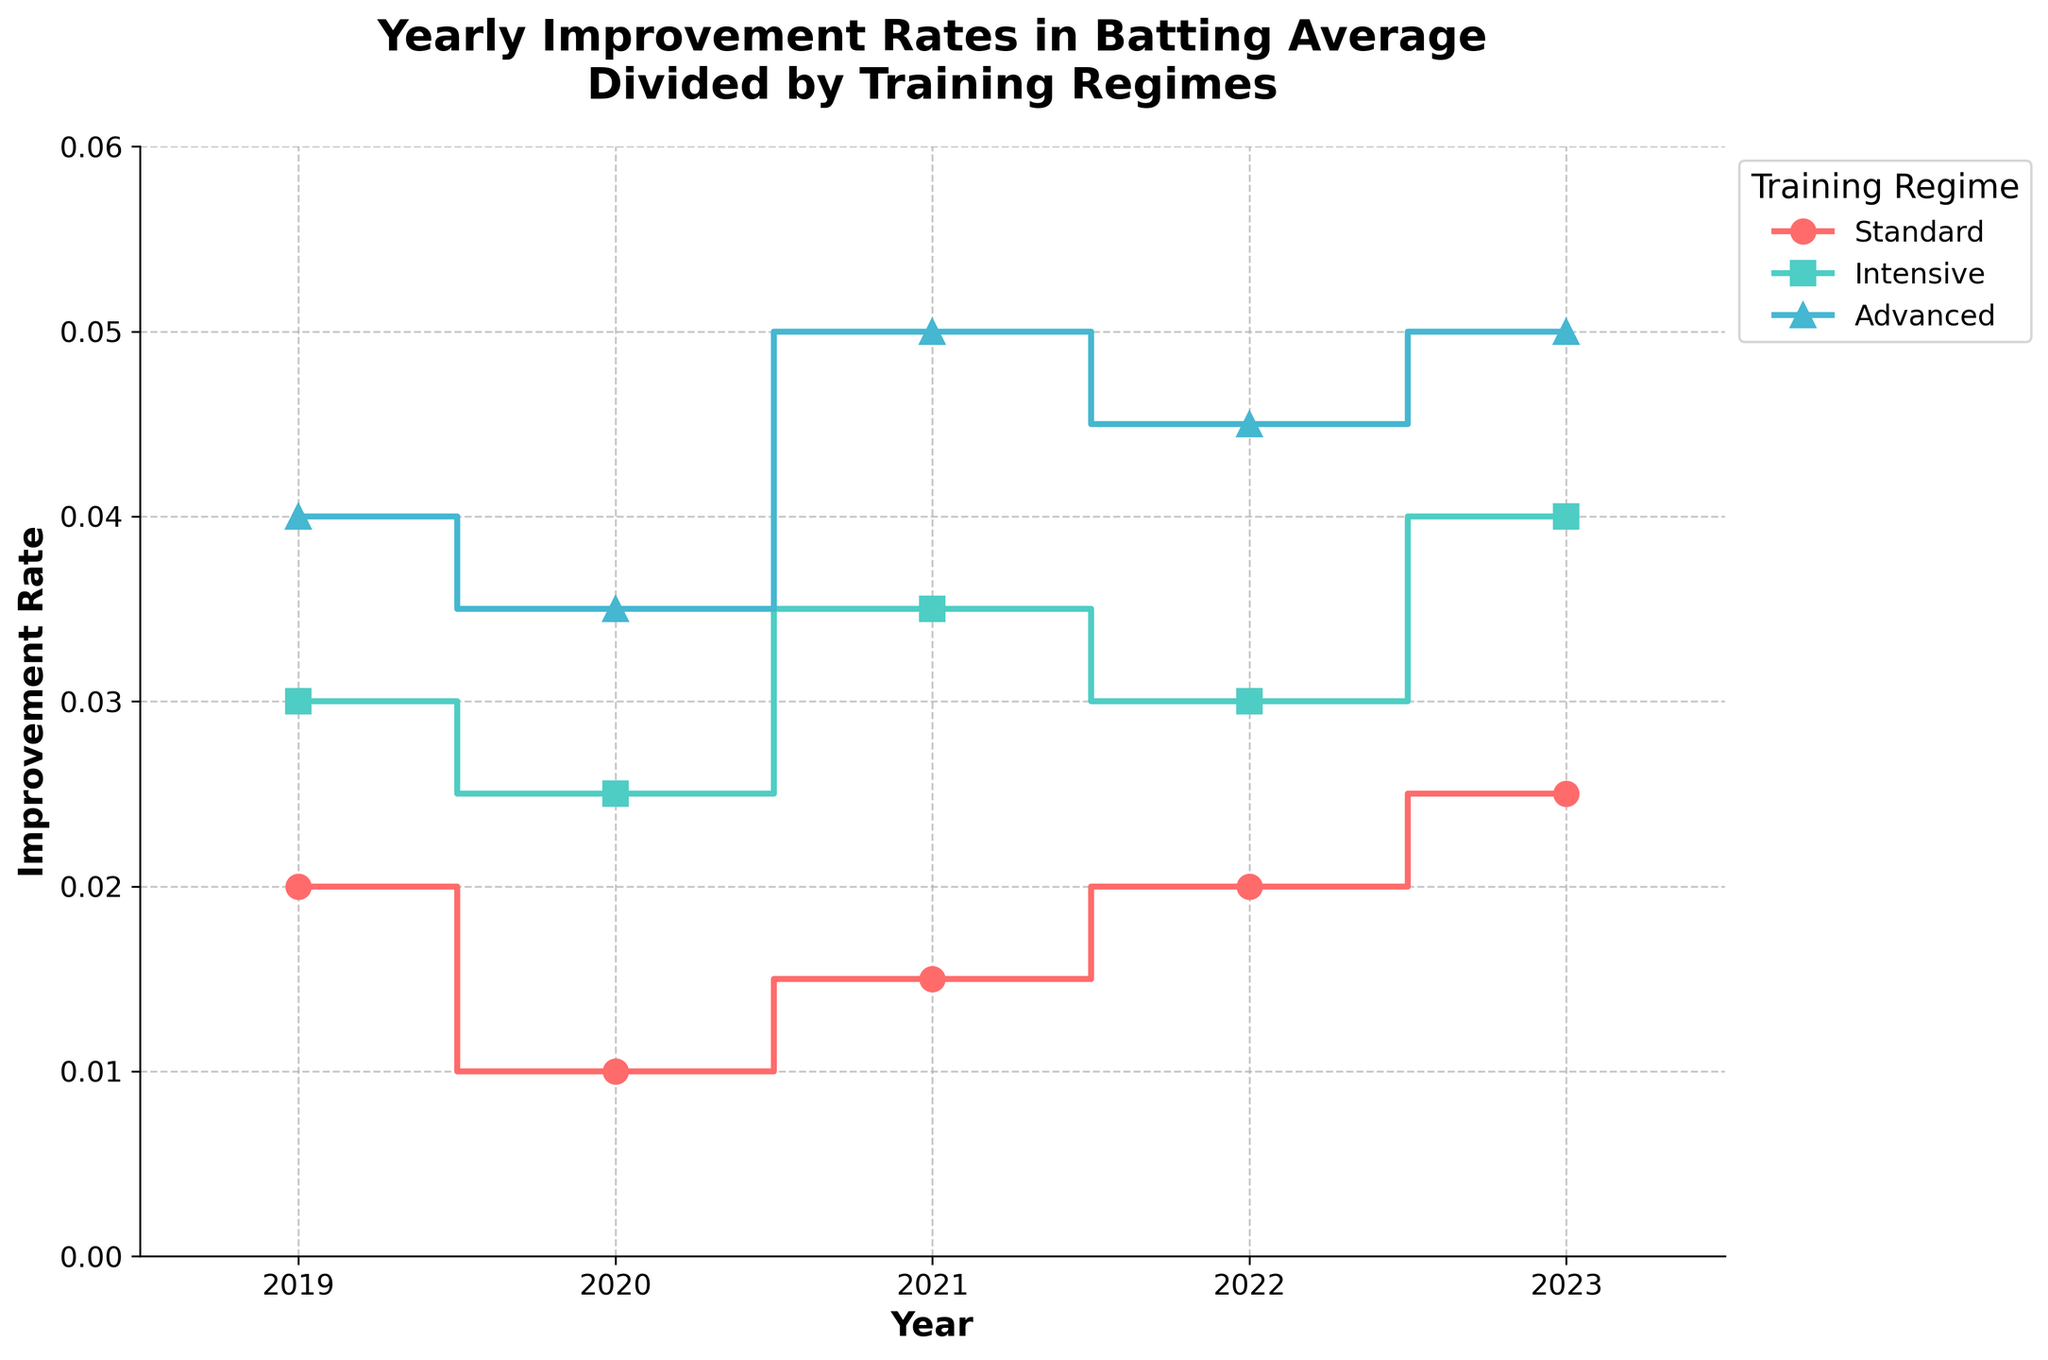Which training regime has the highest improvement rate in 2019? By looking at the plot for the year 2019, observe the y-values of the step plots for each regime. The highest point indicates the highest improvement rate.
Answer: Advanced What is the overall trend for the Standard training regime from 2019 to 2023? Track the line representing the Standard regime from 2019 to 2023. Notice if the line is moving upwards, downwards, or remains constant overall.
Answer: Upwards What is the difference in the improvement rate between Intensive and Standard training regimes in 2023? Identify the y-values for both the Intensive and Standard regimes in 2023 on the plot. Subtract the Standard regime value from the Intensive regime value.
Answer: 0.015 Which year shows the greatest improvement rate for Chris Evans? Chris Evans follows the Advanced regime. Compare the peak values of the Advanced regime for each year.
Answer: 2023 Are there any years where all three training regimes have the same improvement rate? Examine each year’s segment on the plot to determine whether the y-values (improvement rates) for all three regimes are identical.
Answer: No How does Jane Smith's improvement rate in 2020 compare to her improvement rate in 2023? Jane Smith follows the Intensive regime. Compare the y-values in 2020 and 2023 for the Intensive regime on the plot.
Answer: Lower in 2020 Calculate the average yearly improvement rate for the Standard regime between 2019 and 2023. Sum the y-values (improvement rates) for the Standard regime from 2019 to 2023 and divide by the number of years (5).
Answer: 0.018 What is the trend for the Advanced training regime from 2020 to 2021? Observe the segment of the Advanced regime’s line from 2020 to 2021 and note whether it is increasing, decreasing, or staying the same.
Answer: Increasing Among the three training regimes, which one shows the most consistent yearly improvement rate? Assess the lines for each regime from 2019 to 2023 and determine which has the least variation (flattest line).
Answer: Advanced 